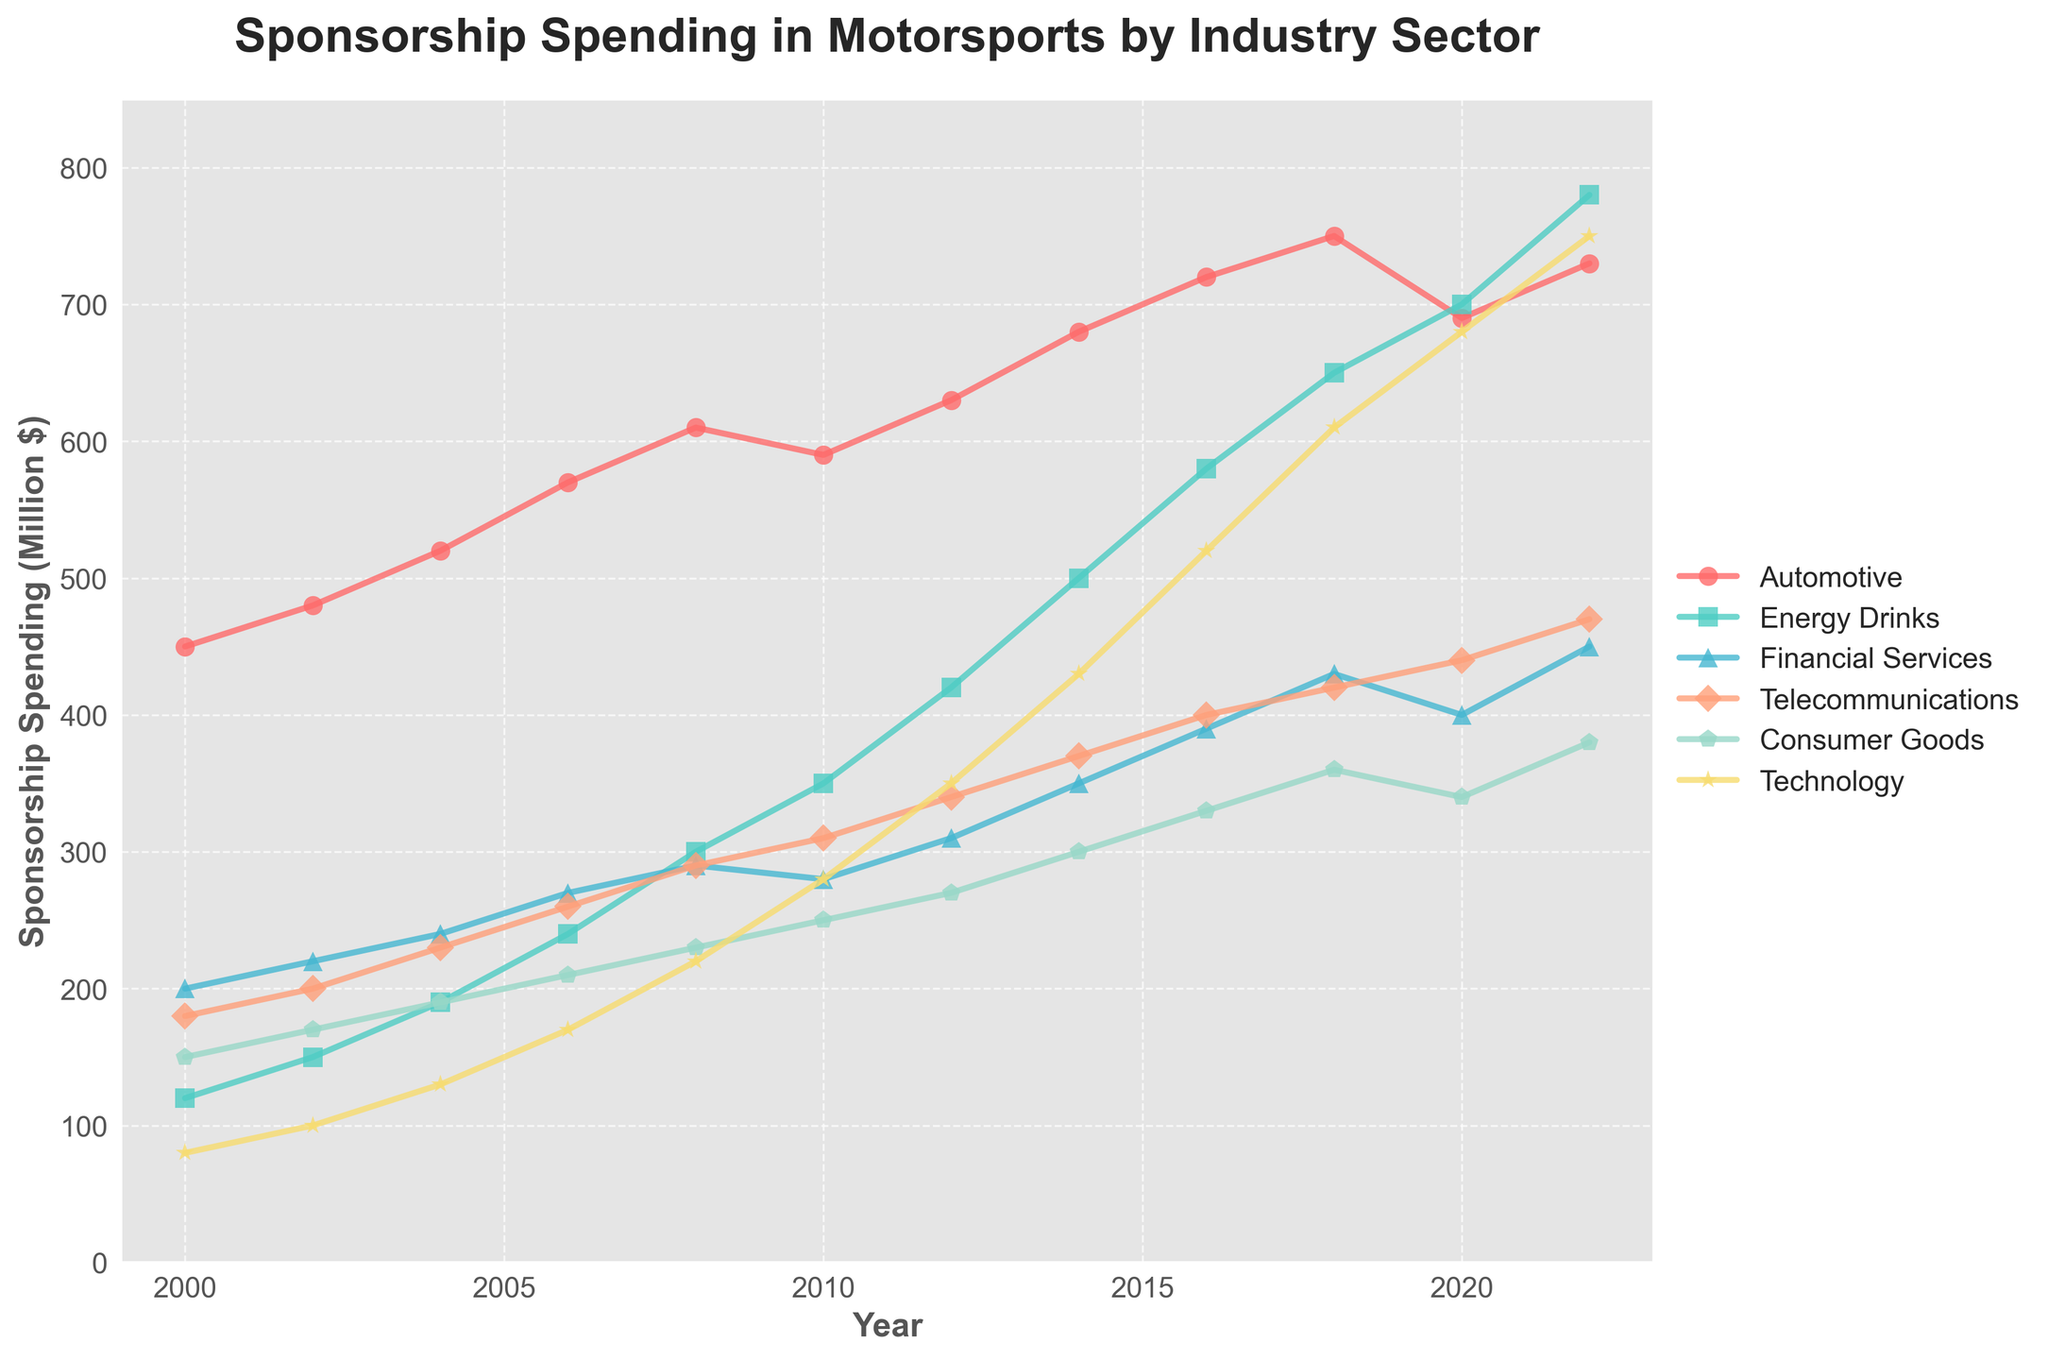What's the trend in sponsorship spending for the Technology sector from 2000 to 2022? By observing the plot, we see that the Technology sector starts at around 80 million dollars in 2000 and consistently increases over the years, reaching approximately 750 million dollars in 2022. Thus, the trend is upward.
Answer: Upward Which sector had the highest sponsorship spending in 2008? By looking at the highest points on the plot for the year 2008, we see that the Automotive sector had the highest spending, at around 610 million dollars.
Answer: Automotive Between 2010 and 2018, how much did the Energy Drinks sector's spending increase? The spending in 2010 was 350 million dollars and in 2018 it was 650 million dollars. To find the increase, we calculate 650 - 350 = 300 million dollars.
Answer: 300 million dollars Which sector's spending remained relatively stable after 2010? By looking at the smoothness and change in the plot lines after 2010, it appears that the Financial Services sector's spending remained relatively stable, fluctuating only slightly around 300 to 400 million dollars.
Answer: Financial Services In which year did the Consumer Goods sector see the sharpest increase in sponsorship spending, and what was the increase? By observing the steepest slope for the Consumer Goods sector plot line, the sharpest increase appears between 2012 and 2014. The spending increased from 270 million dollars in 2012 to 300 million dollars in 2014, making the increase 30 million dollars.
Answer: 2014, 30 million dollars Compare the sponsorship spending for the Automotive and Technology sectors in 2020. Which had higher spending, and by how much? The plot shows that in 2020, Automotive sector spending was at 690 million dollars, while Technology sector spending was at 680 million dollars. The difference is 690 - 680 = 10 million dollars. So, Automotive had higher spending by 10 million dollars.
Answer: Automotive, 10 million dollars Which sector showed the most consistent upward trend from 2000 to 2022? By comparing the smoothness and consistency of the upward trends in all sectors from 2000 to 2022, the Technology sector appears to have the most consistent upward trend.
Answer: Technology What is the average sponsorship spending for the Telecommunications sector over the entire period? Adding up the spending values from 2000 to 2022 for the Telecommunications sector gives us 180 + 200 + 230 + 260 + 290 + 310 + 340 + 370 + 400 + 420 + 440 + 470 = 4110 million dollars. Dividing by the 12 years gives us an average of 4110 / 12 ≈ 342.5 million dollars.
Answer: 342.5 million dollars 